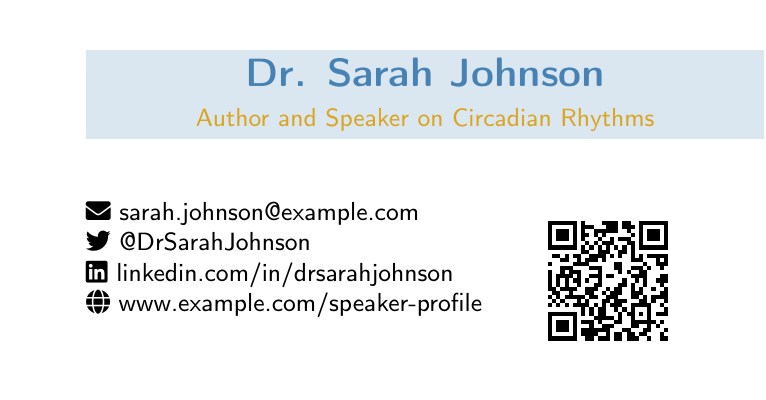What is the name of the author? The author's name is prominently displayed in the document.
Answer: Dr. Sarah Johnson What is the title mentioned on the card? The title describes the author's profession in relation to circadian rhythms.
Answer: Author and Speaker on Circadian Rhythms What is the email address provided? The document lists the author's email for contact purposes.
Answer: sarah.johnson@example.com How many upcoming speaking engagements are listed? The total number of speaking engagements is indicated in the upcoming events section.
Answer: 2 What is the name of the new book mentioned? The document highlights the title of the author's latest book.
Answer: The Circadian Code What is the primary focus of the book? The brief description of the book summarizes its main theme related to health.
Answer: Optimize your health through the power of body clocks What social media platform is the author on? The author's social media presence is given in the contact information section.
Answer: Twitter What type of QR code is included in the document? The document specifies that the QR code provides access to a particular service related to consultations.
Answer: Booking page Which event is mentioned first in the upcoming engagements? The order of the events indicates the sequence of the author's upcoming speaking engagements.
Answer: TEDx Health 2023 